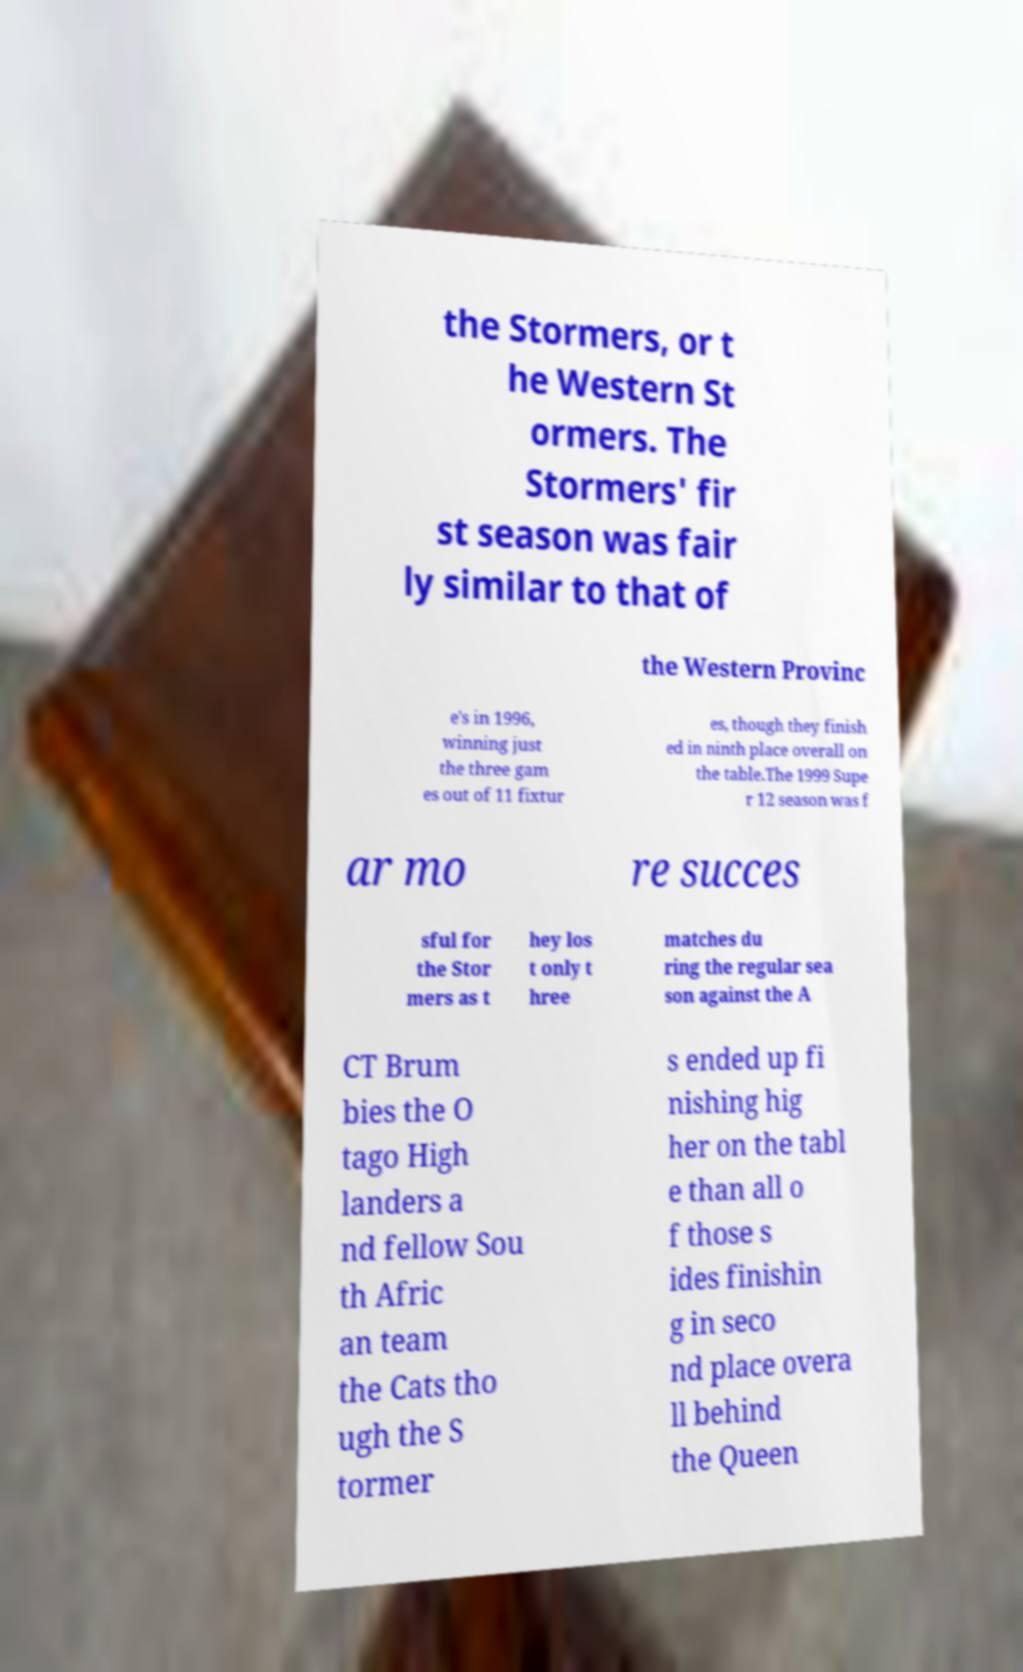Can you read and provide the text displayed in the image?This photo seems to have some interesting text. Can you extract and type it out for me? the Stormers, or t he Western St ormers. The Stormers' fir st season was fair ly similar to that of the Western Provinc e's in 1996, winning just the three gam es out of 11 fixtur es, though they finish ed in ninth place overall on the table.The 1999 Supe r 12 season was f ar mo re succes sful for the Stor mers as t hey los t only t hree matches du ring the regular sea son against the A CT Brum bies the O tago High landers a nd fellow Sou th Afric an team the Cats tho ugh the S tormer s ended up fi nishing hig her on the tabl e than all o f those s ides finishin g in seco nd place overa ll behind the Queen 